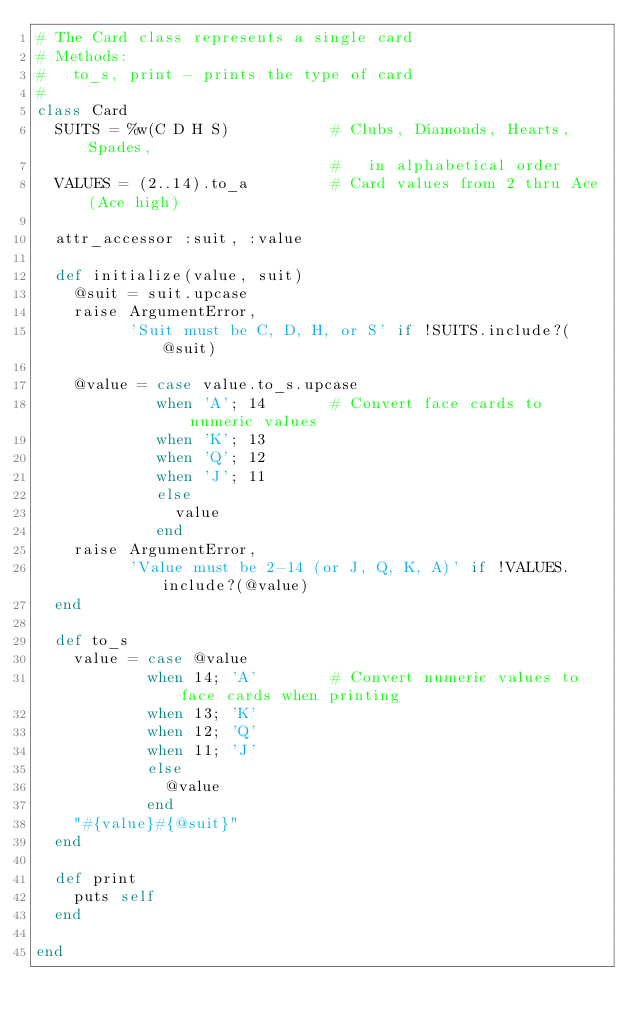Convert code to text. <code><loc_0><loc_0><loc_500><loc_500><_Ruby_># The Card class represents a single card
# Methods:
#   to_s, print - prints the type of card
#
class Card
  SUITS = %w(C D H S)           # Clubs, Diamonds, Hearts, Spades,
                                #   in alphabetical order
  VALUES = (2..14).to_a         # Card values from 2 thru Ace (Ace high)
  
  attr_accessor :suit, :value

  def initialize(value, suit)
    @suit = suit.upcase
    raise ArgumentError,
          'Suit must be C, D, H, or S' if !SUITS.include?(@suit)

    @value = case value.to_s.upcase
             when 'A'; 14       # Convert face cards to numeric values
             when 'K'; 13
             when 'Q'; 12
             when 'J'; 11
             else
               value
             end
    raise ArgumentError,
          'Value must be 2-14 (or J, Q, K, A)' if !VALUES.include?(@value)
  end

  def to_s
    value = case @value
            when 14; 'A'        # Convert numeric values to face cards when printing
            when 13; 'K'
            when 12; 'Q'
            when 11; 'J'
            else
              @value
            end
    "#{value}#{@suit}"
  end

  def print
    puts self
  end

end
</code> 